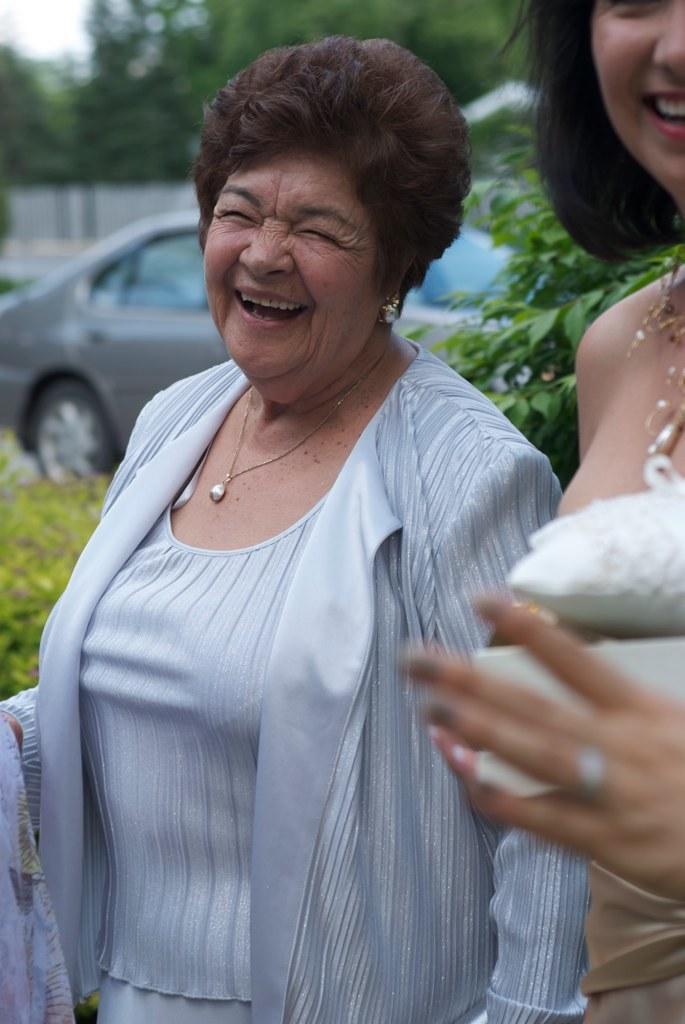Could you give a brief overview of what you see in this image? In this picture i see few woman standing and is see a car parked and few trees and i see smile on their faces. 